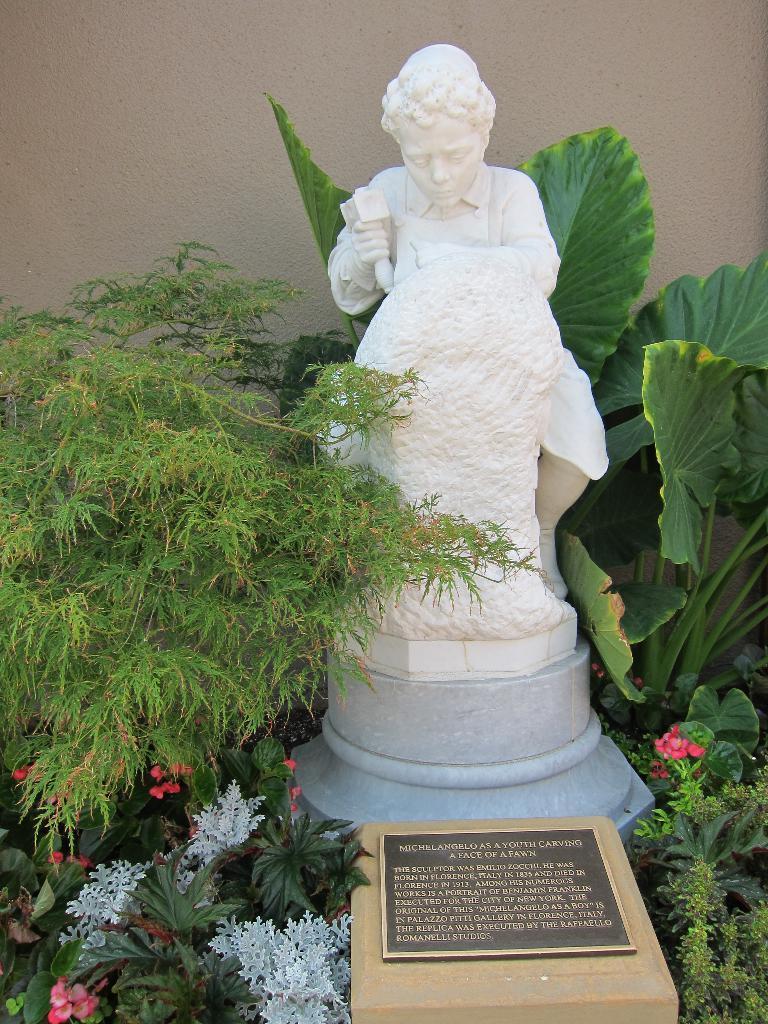Please provide a concise description of this image. In this picture we can see a statue of a person and a stone and in front the statue there is a headstone and flower plants. Behind the statue there is a wall. 